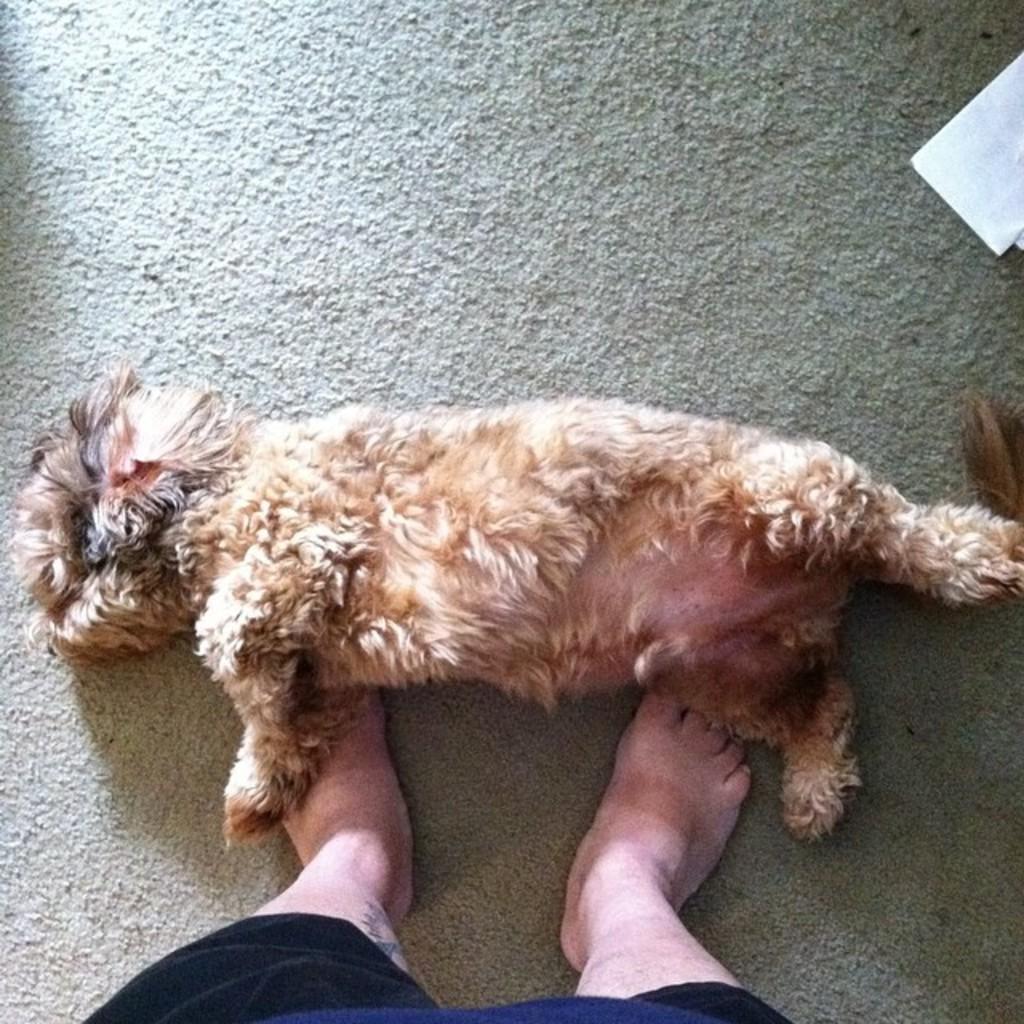Describe this image in one or two sentences. In this picture we can see a person at the bottom, we can see an animal laying, there is a mat at the bottom. 